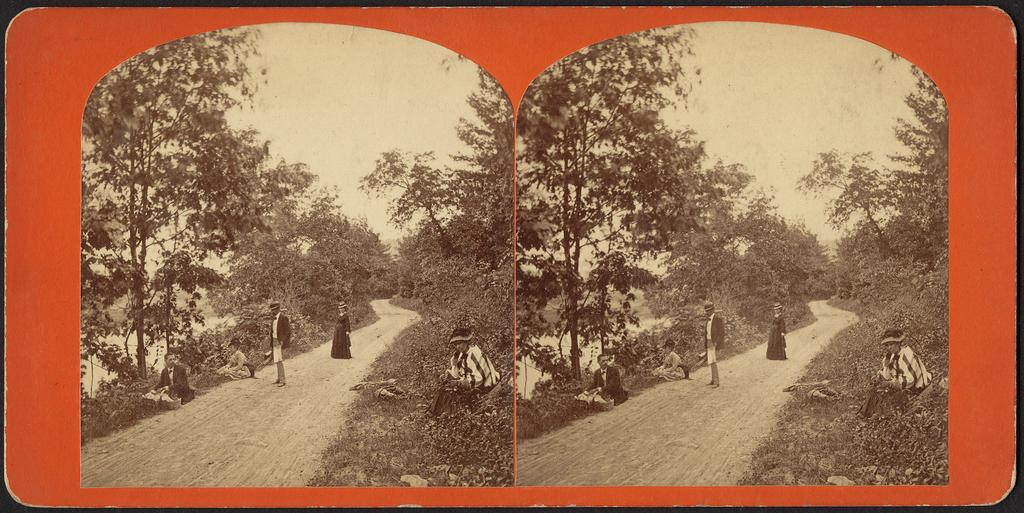What type of artwork is the image? The image is a collage. How many black and white images are in the collage? There are two black and white images in the collage. What is depicted in the black and white images? The black and white images contain trees and people. What are the people in the black and white images doing? Some people are standing on the road, and some are sitting in the black and white images. What type of curtain can be seen in the image? There is no curtain present in the image; it is a collage of black and white images containing trees and people. How many boots are visible in the image? There are no boots visible in the image; it is a collage of black and white images containing trees and people. 